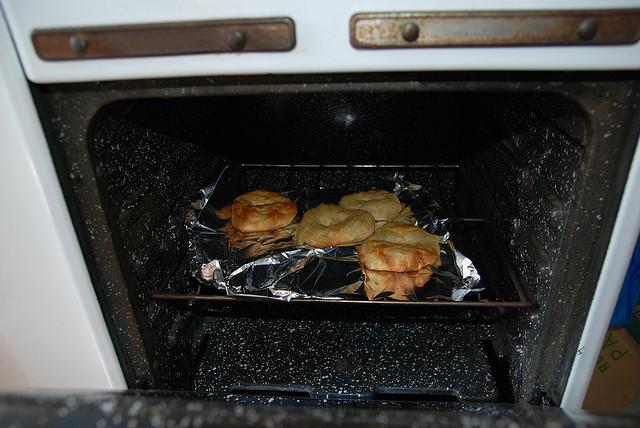What is safest to touch without being burned? Please explain your reasoning. foil. The product made out of aluminum does not retain the heat like pans and other items. 